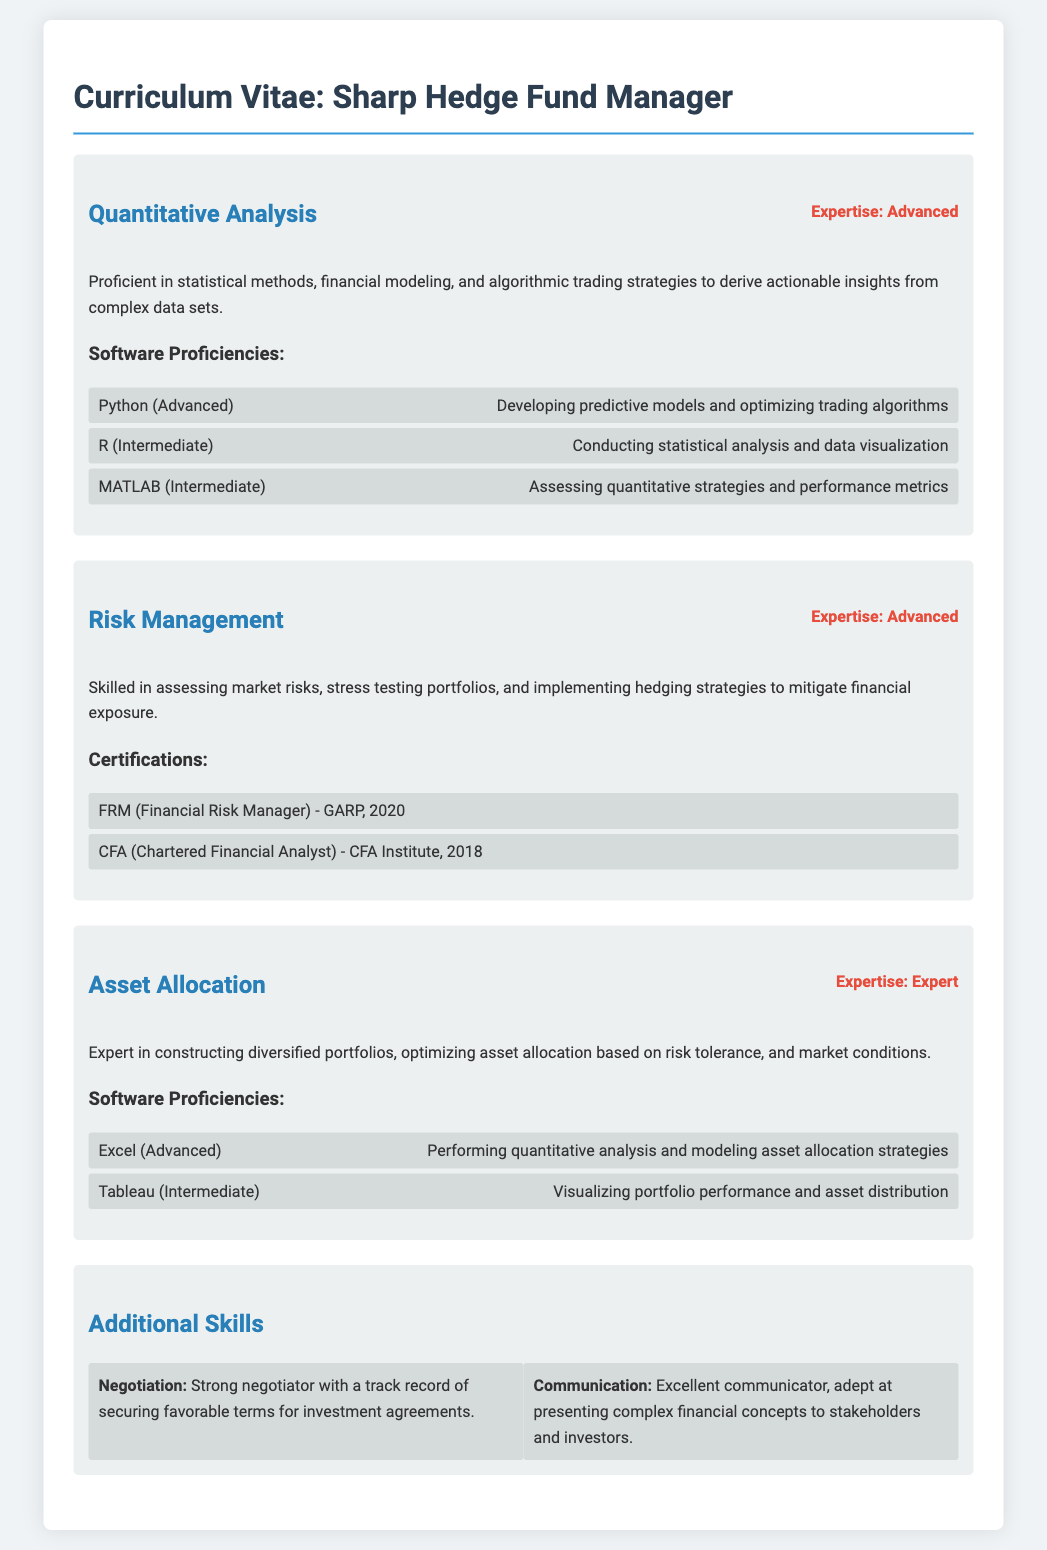What is the expertise level in Quantitative Analysis? The expertise level for Quantitative Analysis is stated as Advanced.
Answer: Advanced Which software is mentioned as Advanced proficiency for predictive models? Python is indicated as having Advanced proficiency for developing predictive models.
Answer: Python What certification does the individual hold that is related to risk management? The document lists the FRM certification and the issuer is GARP in 2020.
Answer: FRM (Financial Risk Manager) - GARP, 2020 What is the individual’s expertise level in Asset Allocation? The document states that the expertise level in Asset Allocation is Expert.
Answer: Expert Which software is used for visualizing portfolio performance? Tableau is highlighted as an Intermediate proficiency for visualizing portfolio performance.
Answer: Tableau What additional skill is emphasized in the document related to interpersonal abilities? The document highlights communication skills indicating the individual is excellent at presenting complex concepts.
Answer: Communication What year did the individual obtain the CFA certification? The CFA certification was obtained in 2018 as per the document.
Answer: 2018 What are the two programming tools listed under Quantitative Analysis? The tools mentioned in the document for Quantitative Analysis are Python and R.
Answer: Python and R How many years of experience are implied by the certifications obtained? There are two distinct certifications mentioned that were attained, implying at least a total of three years since the earliest certification in 2018.
Answer: Three years 